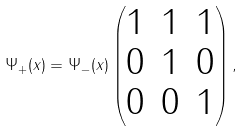<formula> <loc_0><loc_0><loc_500><loc_500>\Psi _ { + } ( x ) = \Psi _ { - } ( x ) \begin{pmatrix} 1 & 1 & 1 \\ 0 & 1 & 0 \\ 0 & 0 & 1 \end{pmatrix} ,</formula> 